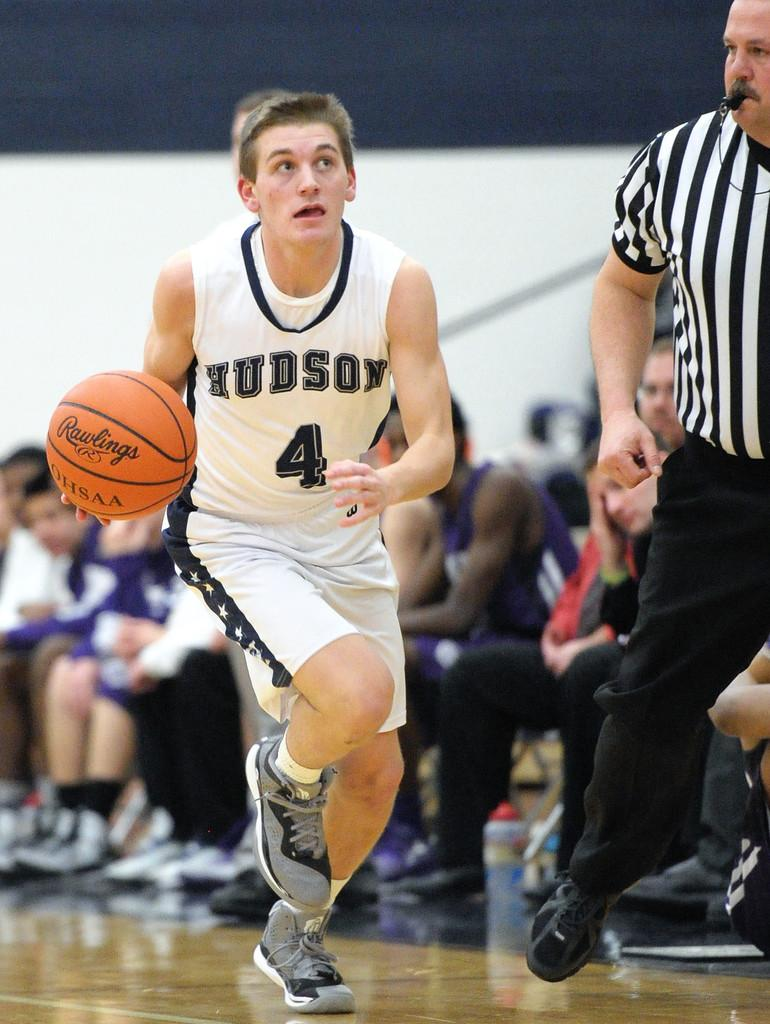<image>
Share a concise interpretation of the image provided. A basketball player has the team name Hudson on his jersey. 